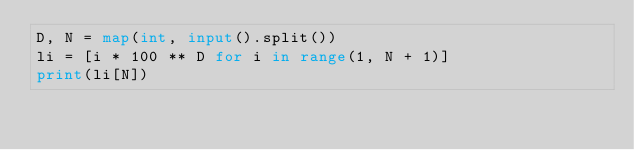Convert code to text. <code><loc_0><loc_0><loc_500><loc_500><_Python_>D, N = map(int, input().split())
li = [i * 100 ** D for i in range(1, N + 1)]
print(li[N])
</code> 